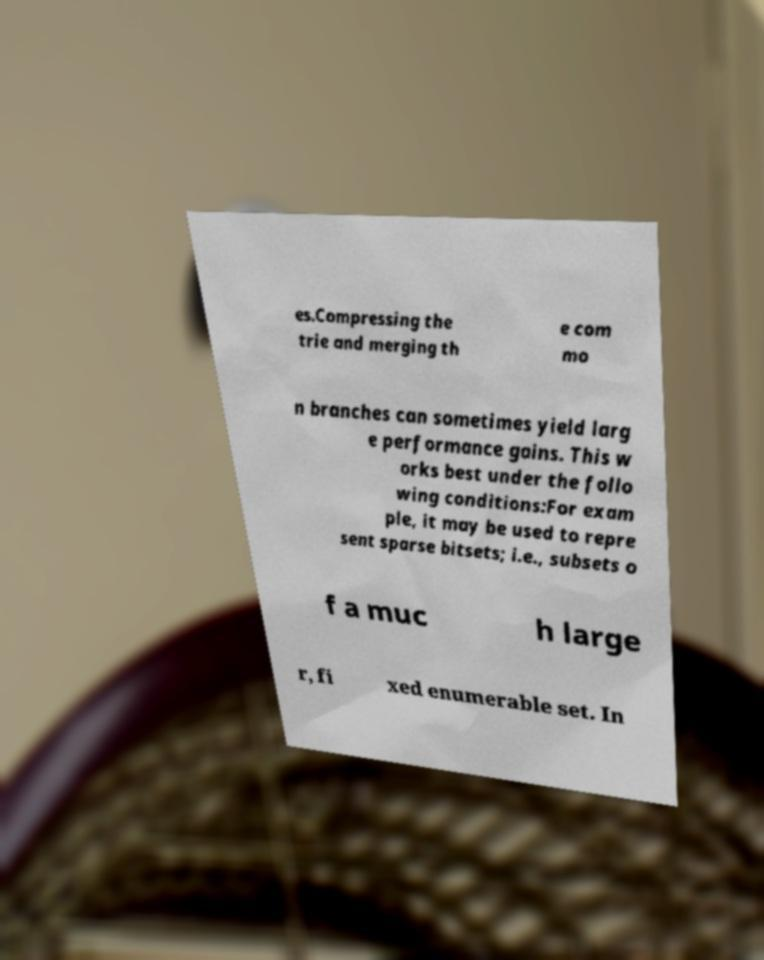What messages or text are displayed in this image? I need them in a readable, typed format. es.Compressing the trie and merging th e com mo n branches can sometimes yield larg e performance gains. This w orks best under the follo wing conditions:For exam ple, it may be used to repre sent sparse bitsets; i.e., subsets o f a muc h large r, fi xed enumerable set. In 